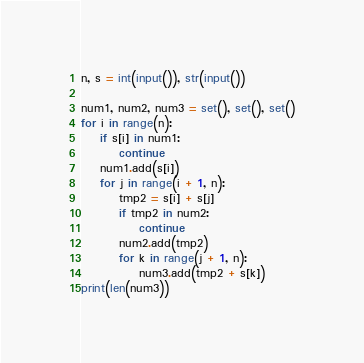Convert code to text. <code><loc_0><loc_0><loc_500><loc_500><_Python_>n, s = int(input()), str(input())

num1, num2, num3 = set(), set(), set()
for i in range(n):
    if s[i] in num1:
        continue
    num1.add(s[i])
    for j in range(i + 1, n):
        tmp2 = s[i] + s[j]
        if tmp2 in num2:
            continue
        num2.add(tmp2)
        for k in range(j + 1, n):
            num3.add(tmp2 + s[k])
print(len(num3))
</code> 